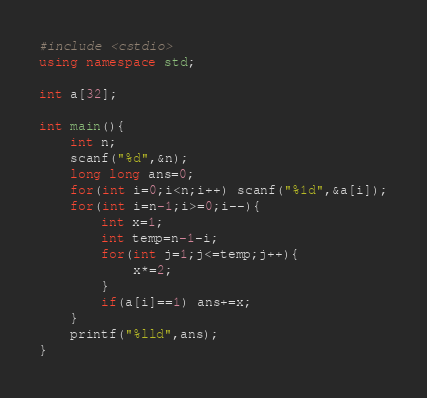Convert code to text. <code><loc_0><loc_0><loc_500><loc_500><_C++_>#include <cstdio>
using namespace std;

int a[32];

int main(){
	int n;
	scanf("%d",&n);
	long long ans=0;
	for(int i=0;i<n;i++) scanf("%1d",&a[i]);
	for(int i=n-1;i>=0;i--){
		int x=1;
		int temp=n-1-i;
		for(int j=1;j<=temp;j++){
			x*=2;	
		}
		if(a[i]==1) ans+=x;
	}
	printf("%lld",ans);
}
</code> 